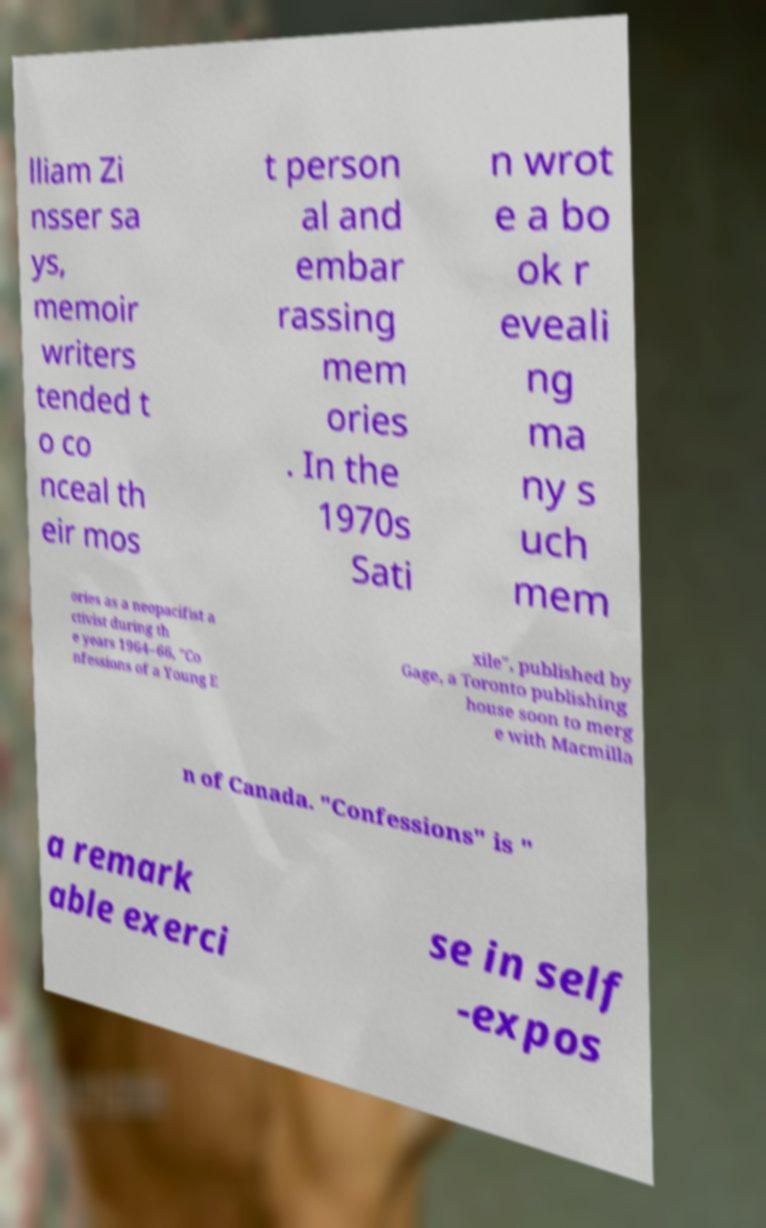Can you accurately transcribe the text from the provided image for me? lliam Zi nsser sa ys, memoir writers tended t o co nceal th eir mos t person al and embar rassing mem ories . In the 1970s Sati n wrot e a bo ok r eveali ng ma ny s uch mem ories as a neopacifist a ctivist during th e years 1964–66, "Co nfessions of a Young E xile", published by Gage, a Toronto publishing house soon to merg e with Macmilla n of Canada. "Confessions" is " a remark able exerci se in self -expos 